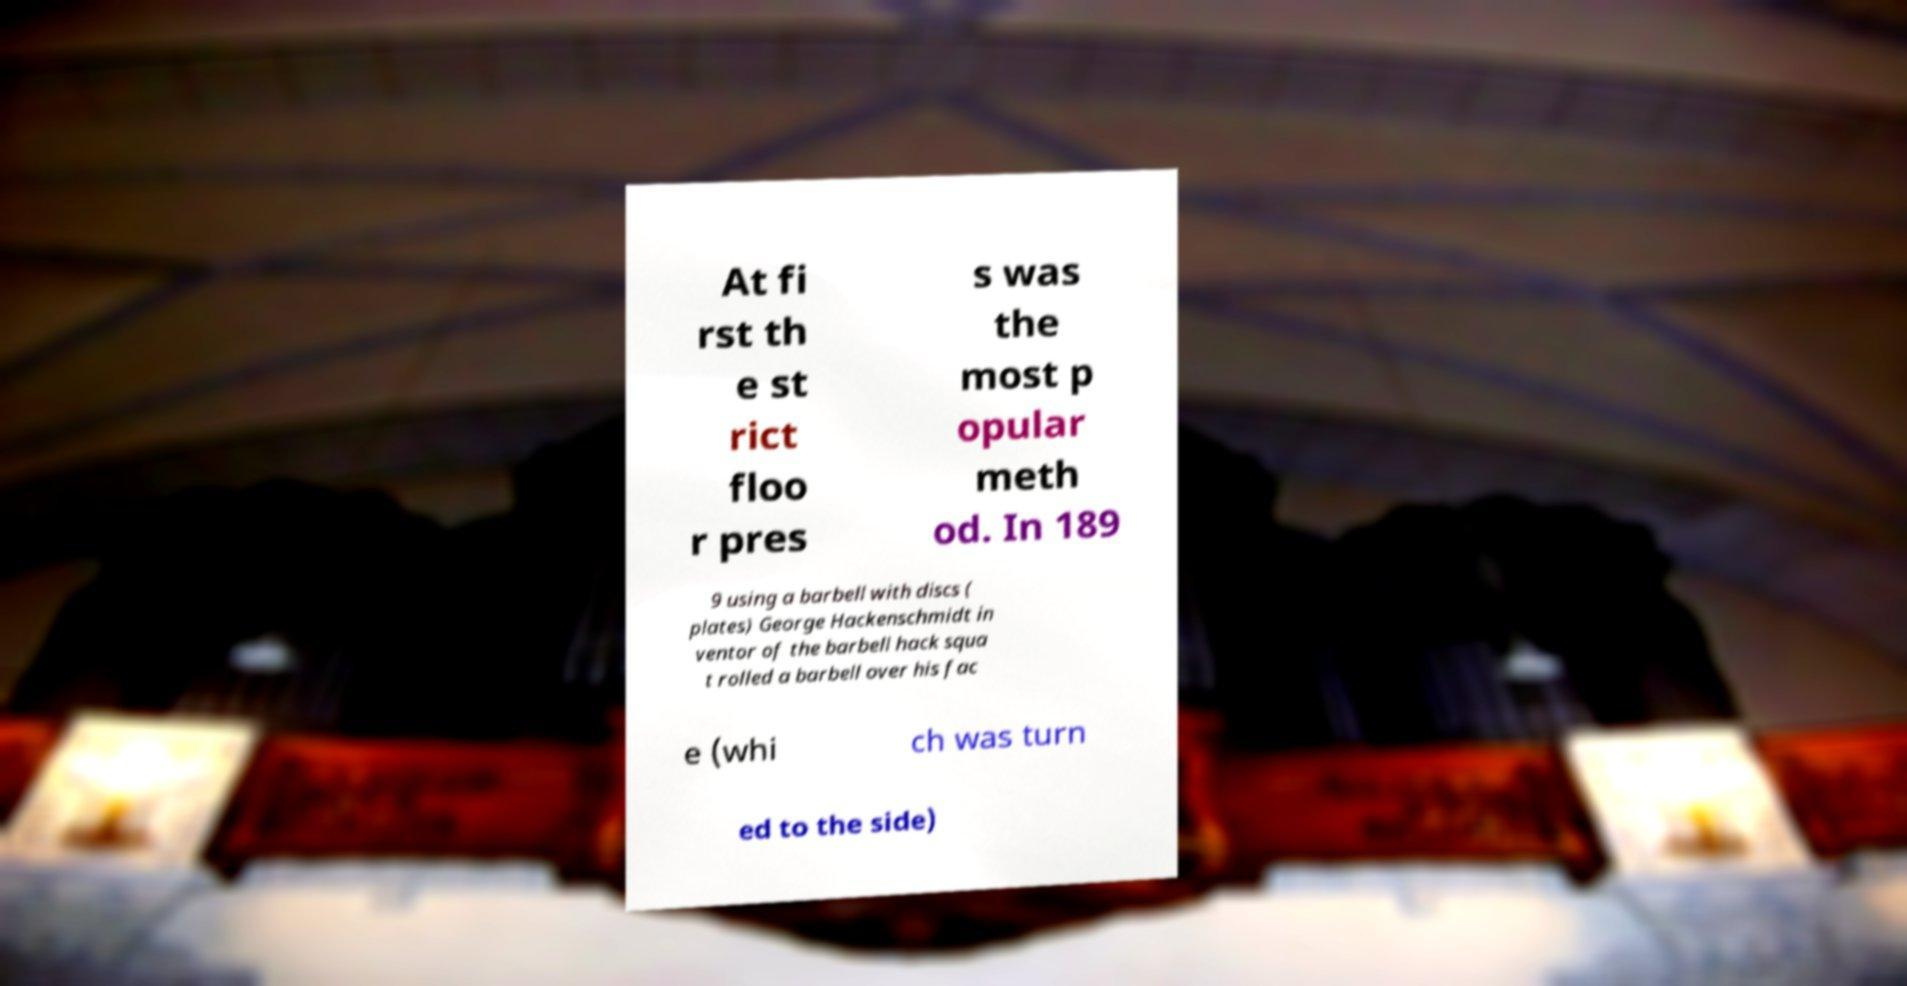Please identify and transcribe the text found in this image. At fi rst th e st rict floo r pres s was the most p opular meth od. In 189 9 using a barbell with discs ( plates) George Hackenschmidt in ventor of the barbell hack squa t rolled a barbell over his fac e (whi ch was turn ed to the side) 